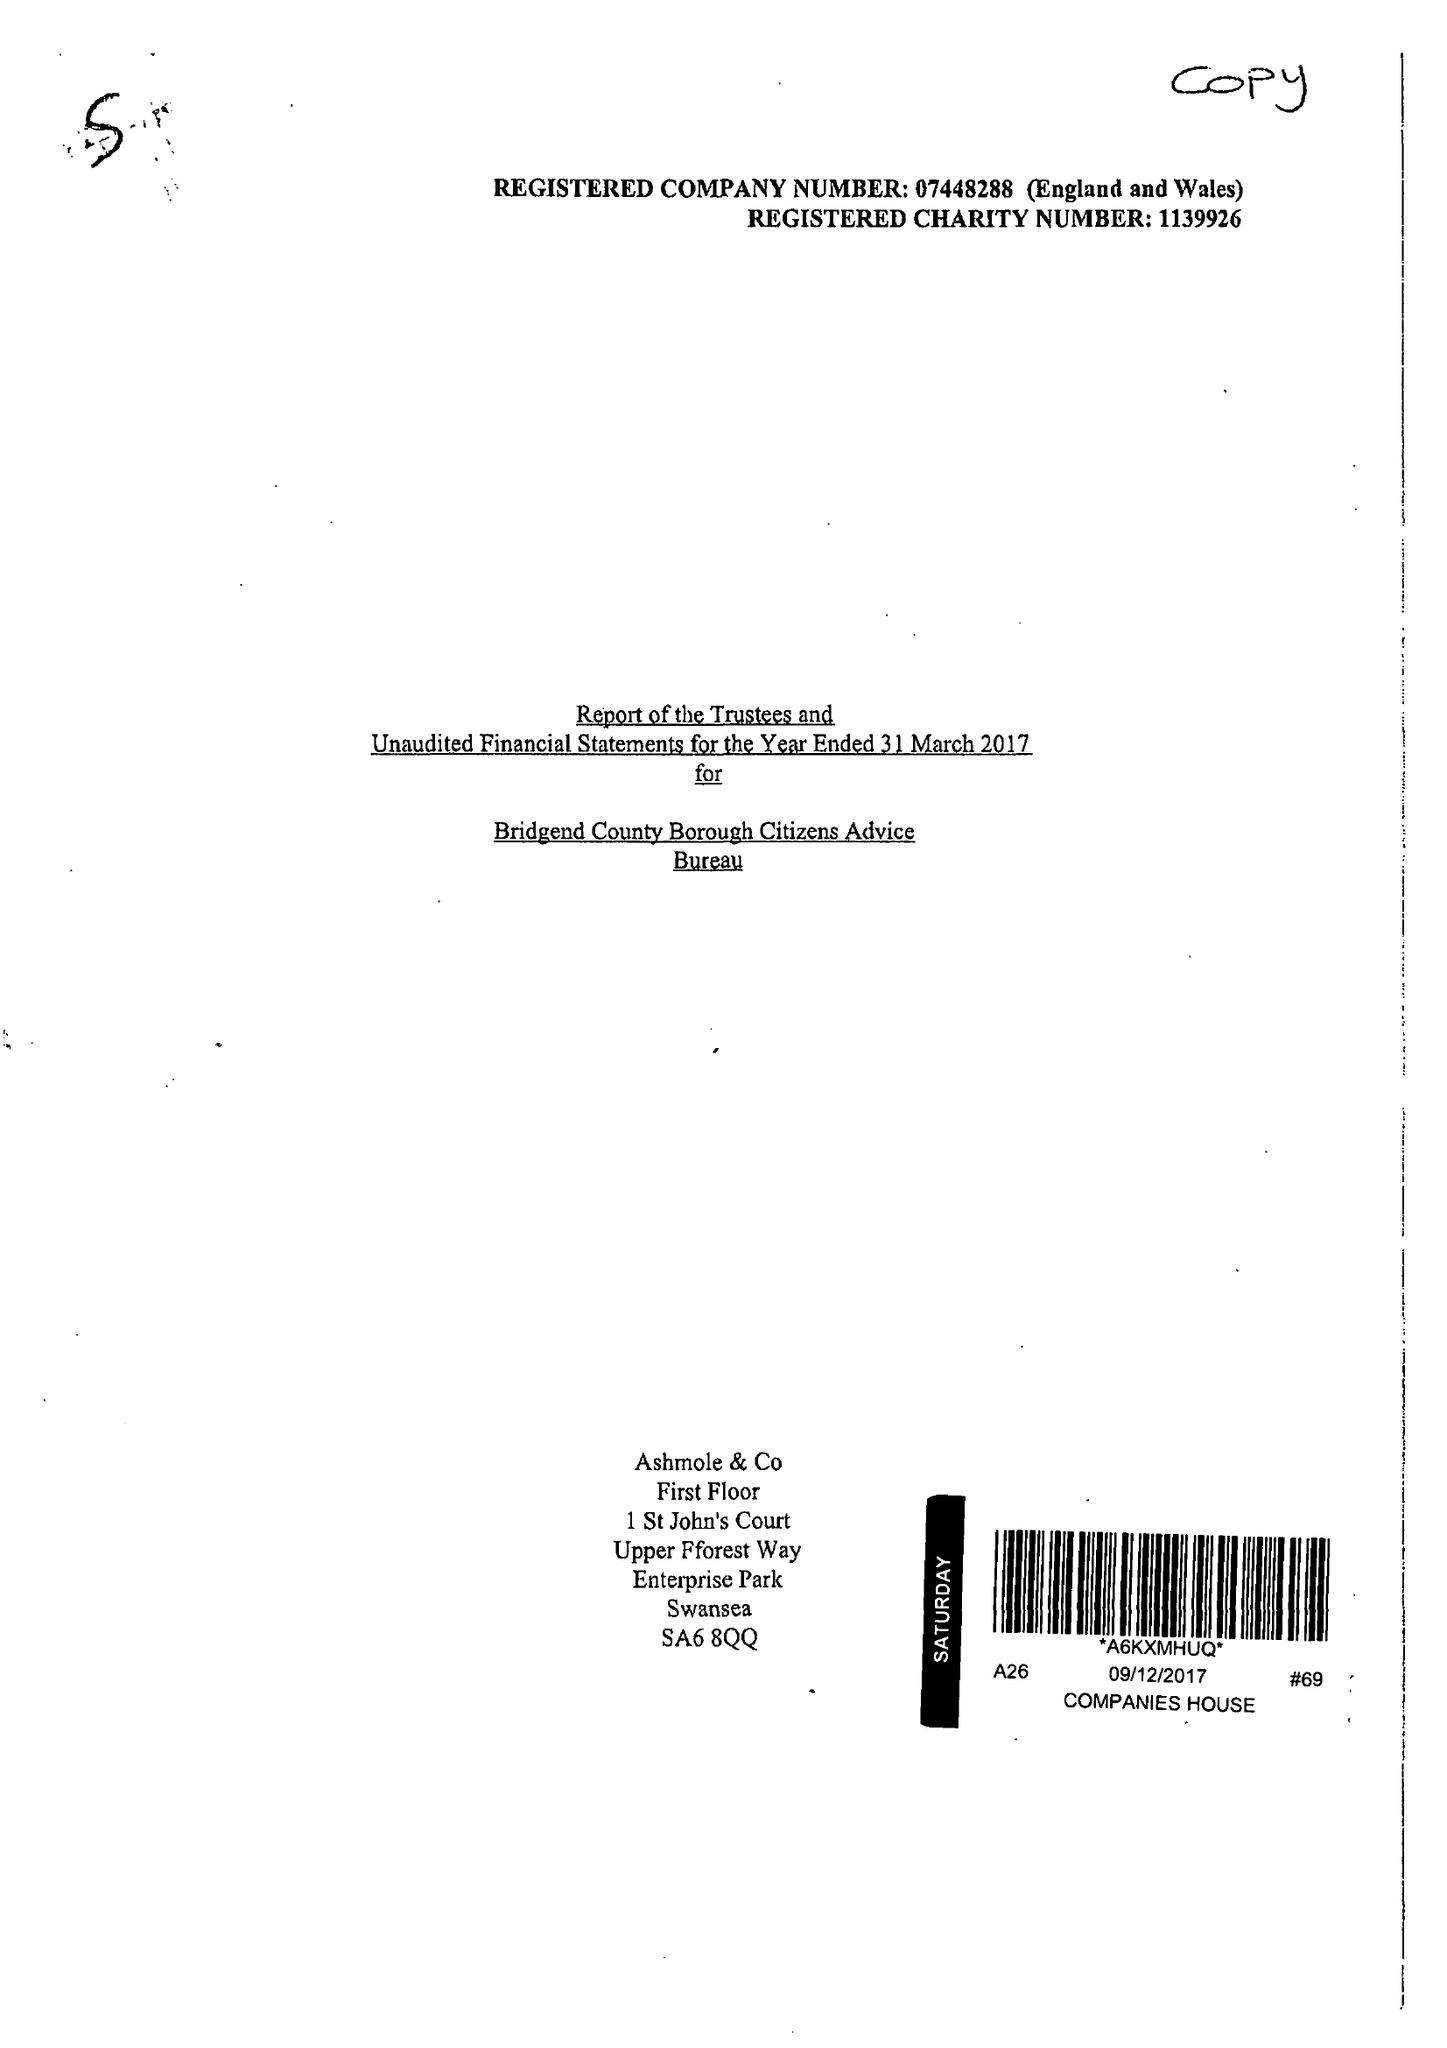What is the value for the spending_annually_in_british_pounds?
Answer the question using a single word or phrase. 454944.00 